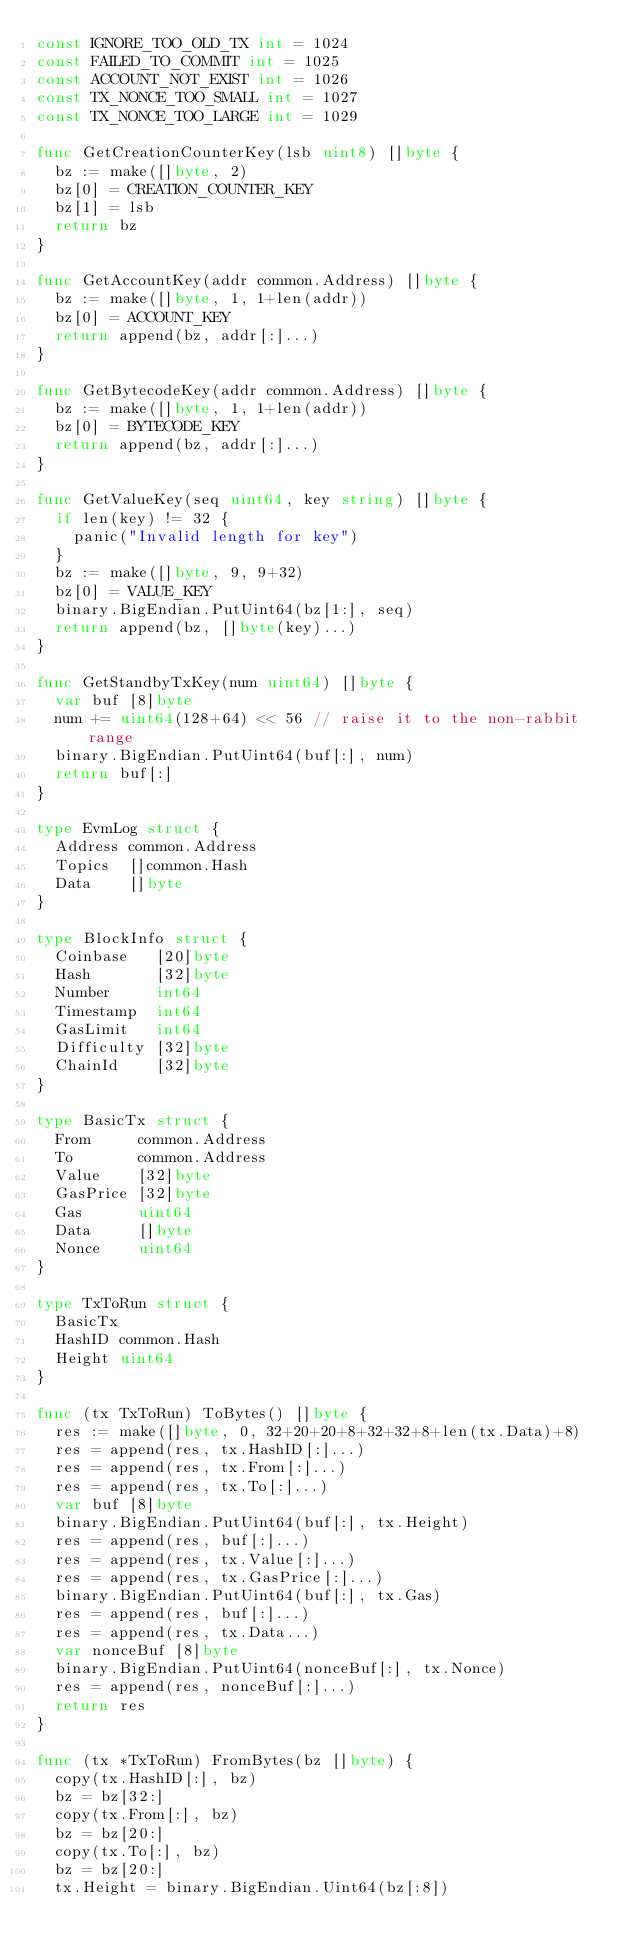<code> <loc_0><loc_0><loc_500><loc_500><_Go_>const IGNORE_TOO_OLD_TX int = 1024
const FAILED_TO_COMMIT int = 1025
const ACCOUNT_NOT_EXIST int = 1026
const TX_NONCE_TOO_SMALL int = 1027
const TX_NONCE_TOO_LARGE int = 1029

func GetCreationCounterKey(lsb uint8) []byte {
	bz := make([]byte, 2)
	bz[0] = CREATION_COUNTER_KEY
	bz[1] = lsb
	return bz
}

func GetAccountKey(addr common.Address) []byte {
	bz := make([]byte, 1, 1+len(addr))
	bz[0] = ACCOUNT_KEY
	return append(bz, addr[:]...)
}

func GetBytecodeKey(addr common.Address) []byte {
	bz := make([]byte, 1, 1+len(addr))
	bz[0] = BYTECODE_KEY
	return append(bz, addr[:]...)
}

func GetValueKey(seq uint64, key string) []byte {
	if len(key) != 32 {
		panic("Invalid length for key")
	}
	bz := make([]byte, 9, 9+32)
	bz[0] = VALUE_KEY
	binary.BigEndian.PutUint64(bz[1:], seq)
	return append(bz, []byte(key)...)
}

func GetStandbyTxKey(num uint64) []byte {
	var buf [8]byte
	num += uint64(128+64) << 56 // raise it to the non-rabbit range
	binary.BigEndian.PutUint64(buf[:], num)
	return buf[:]
}

type EvmLog struct {
	Address common.Address
	Topics  []common.Hash
	Data    []byte
}

type BlockInfo struct {
	Coinbase   [20]byte
	Hash       [32]byte
	Number     int64
	Timestamp  int64
	GasLimit   int64
	Difficulty [32]byte
	ChainId    [32]byte
}

type BasicTx struct {
	From     common.Address
	To       common.Address
	Value    [32]byte
	GasPrice [32]byte
	Gas      uint64
	Data     []byte
	Nonce    uint64
}

type TxToRun struct {
	BasicTx
	HashID common.Hash
	Height uint64
}

func (tx TxToRun) ToBytes() []byte {
	res := make([]byte, 0, 32+20+20+8+32+32+8+len(tx.Data)+8)
	res = append(res, tx.HashID[:]...)
	res = append(res, tx.From[:]...)
	res = append(res, tx.To[:]...)
	var buf [8]byte
	binary.BigEndian.PutUint64(buf[:], tx.Height)
	res = append(res, buf[:]...)
	res = append(res, tx.Value[:]...)
	res = append(res, tx.GasPrice[:]...)
	binary.BigEndian.PutUint64(buf[:], tx.Gas)
	res = append(res, buf[:]...)
	res = append(res, tx.Data...)
	var nonceBuf [8]byte
	binary.BigEndian.PutUint64(nonceBuf[:], tx.Nonce)
	res = append(res, nonceBuf[:]...)
	return res
}

func (tx *TxToRun) FromBytes(bz []byte) {
	copy(tx.HashID[:], bz)
	bz = bz[32:]
	copy(tx.From[:], bz)
	bz = bz[20:]
	copy(tx.To[:], bz)
	bz = bz[20:]
	tx.Height = binary.BigEndian.Uint64(bz[:8])</code> 